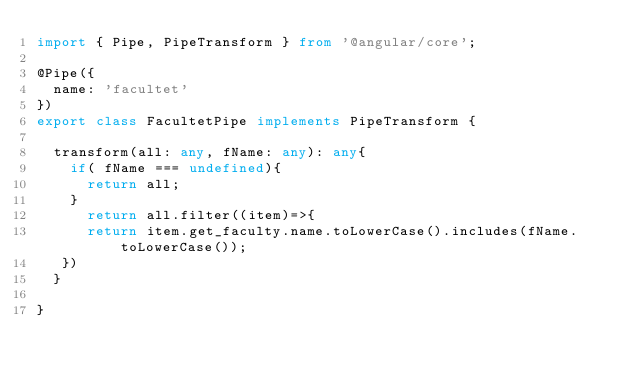<code> <loc_0><loc_0><loc_500><loc_500><_TypeScript_>import { Pipe, PipeTransform } from '@angular/core';

@Pipe({
  name: 'facultet'
})
export class FacultetPipe implements PipeTransform {

  transform(all: any, fName: any): any{
    if( fName === undefined){
      return all;
    }
      return all.filter((item)=>{
      return item.get_faculty.name.toLowerCase().includes(fName.toLowerCase());
   })
  }

}
</code> 